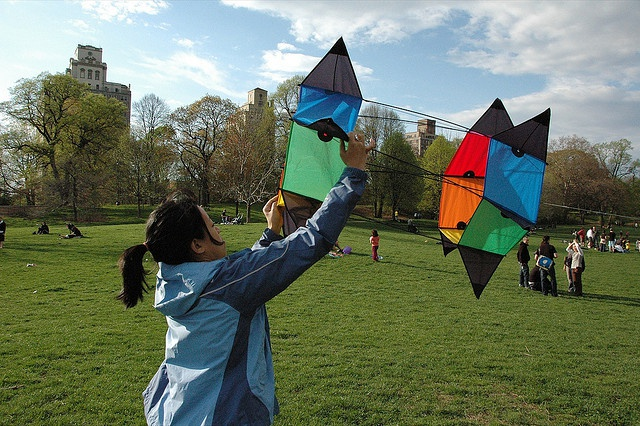Describe the objects in this image and their specific colors. I can see people in lightblue, black, blue, navy, and gray tones, kite in lightblue, black, teal, green, and blue tones, people in lightblue, black, darkgreen, and gray tones, people in lightblue, black, gray, darkgray, and ivory tones, and people in lightblue, black, gray, darkgreen, and maroon tones in this image. 